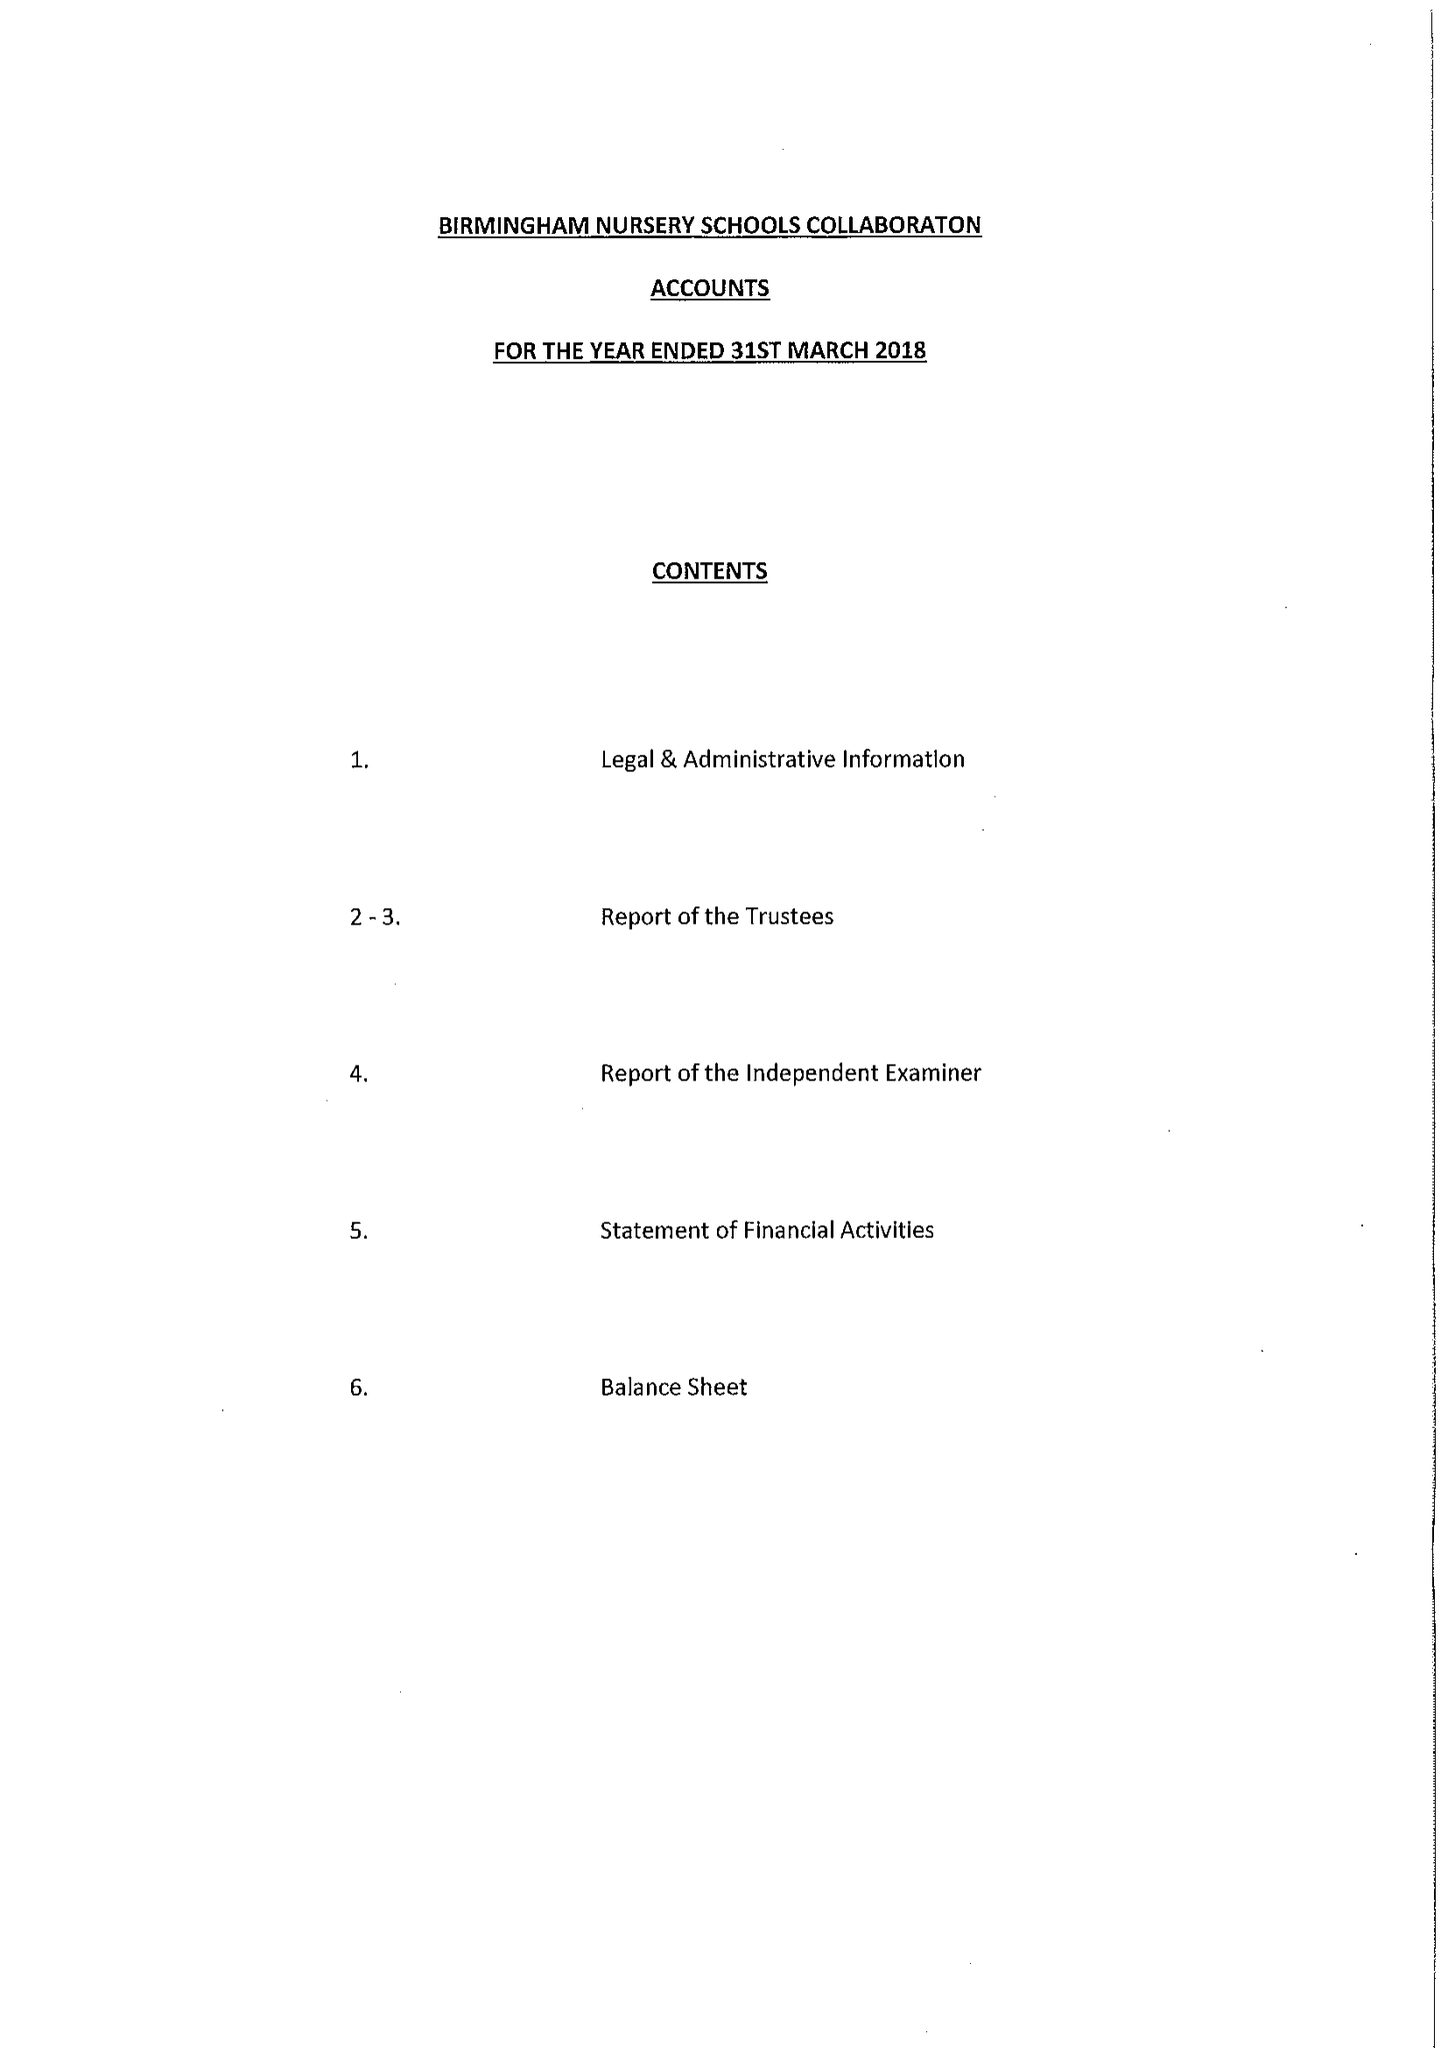What is the value for the address__post_town?
Answer the question using a single word or phrase. BIRMINGHAM 